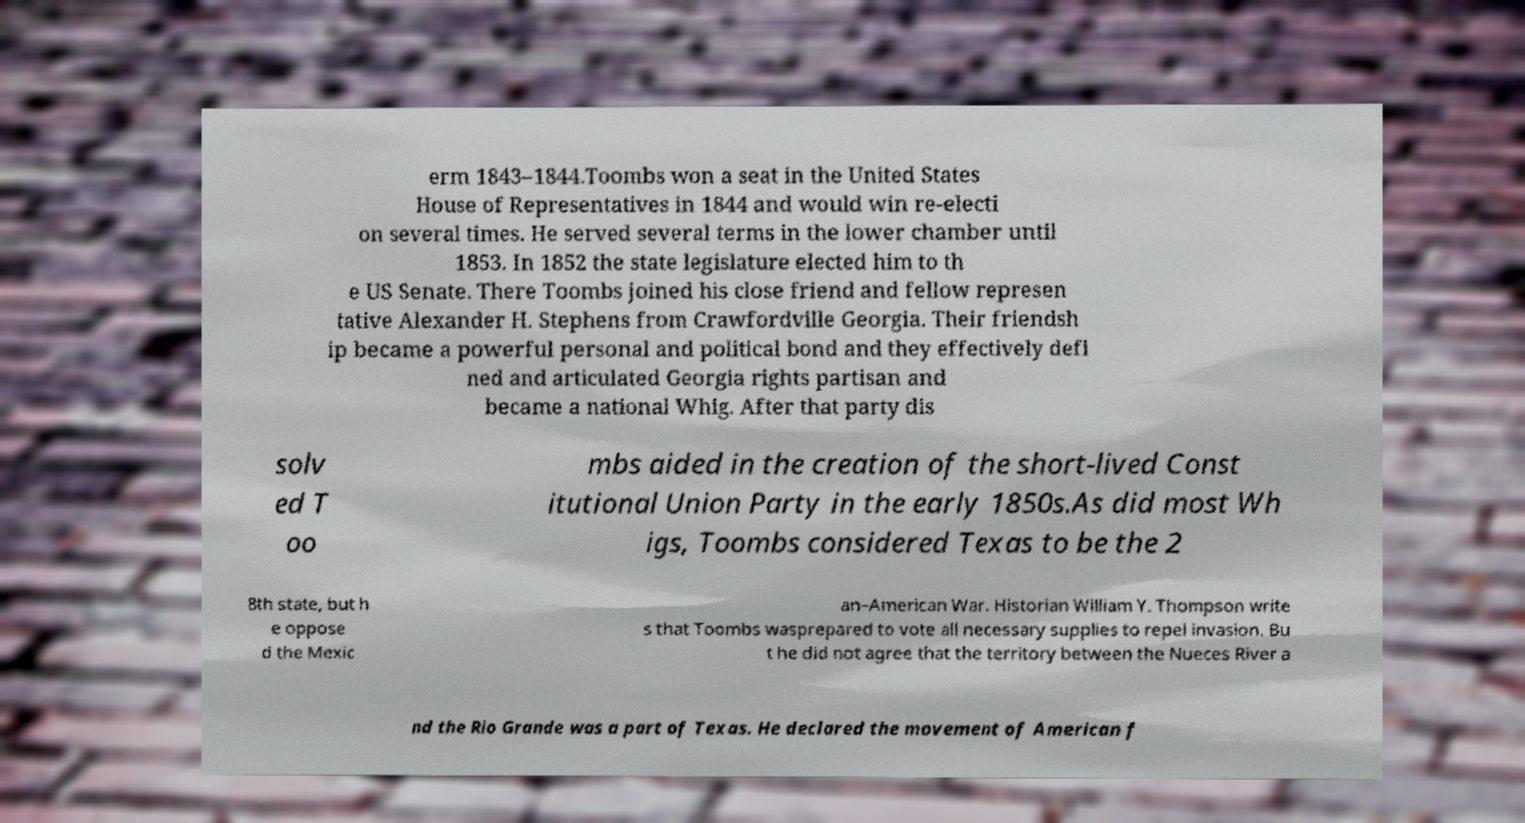Can you read and provide the text displayed in the image?This photo seems to have some interesting text. Can you extract and type it out for me? erm 1843–1844.Toombs won a seat in the United States House of Representatives in 1844 and would win re-electi on several times. He served several terms in the lower chamber until 1853. In 1852 the state legislature elected him to th e US Senate. There Toombs joined his close friend and fellow represen tative Alexander H. Stephens from Crawfordville Georgia. Their friendsh ip became a powerful personal and political bond and they effectively defi ned and articulated Georgia rights partisan and became a national Whig. After that party dis solv ed T oo mbs aided in the creation of the short-lived Const itutional Union Party in the early 1850s.As did most Wh igs, Toombs considered Texas to be the 2 8th state, but h e oppose d the Mexic an–American War. Historian William Y. Thompson write s that Toombs wasprepared to vote all necessary supplies to repel invasion. Bu t he did not agree that the territory between the Nueces River a nd the Rio Grande was a part of Texas. He declared the movement of American f 